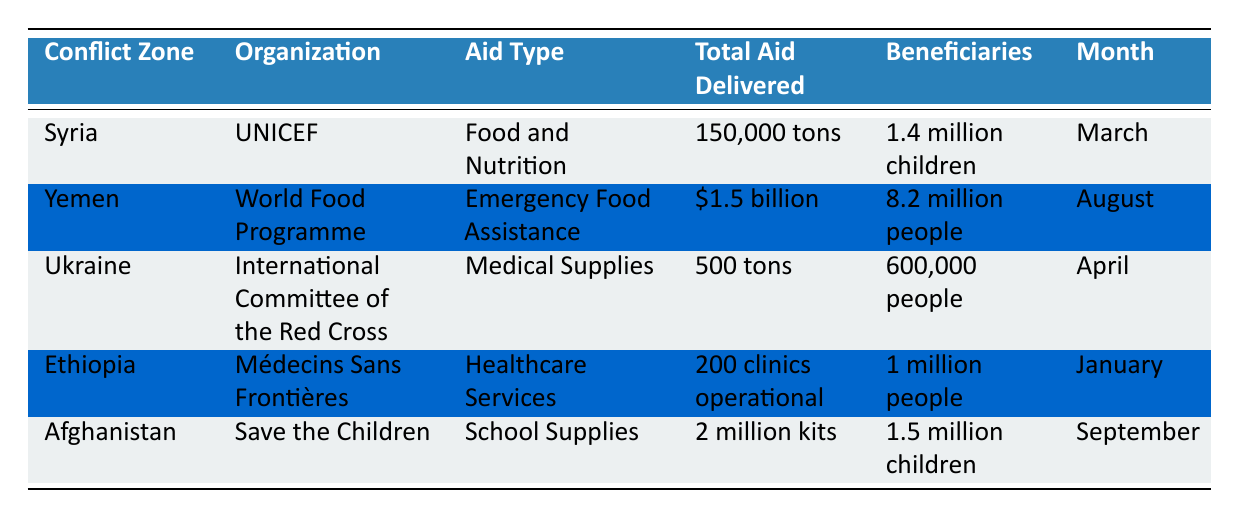What type of aid was delivered in Ukraine? The table indicates that the aid delivered in Ukraine was "Medical Supplies." This information can be found directly under the "Aid Type" column corresponding to the row for Ukraine.
Answer: Medical Supplies Which organization provided aid to Yemen? Looking through the "Organization" column, the entry for Yemen reveals that the "World Food Programme" provided aid. This can be confirmed by checking the row for Yemen.
Answer: World Food Programme How many beneficiaries received aid in Ethiopia? The table shows that 1 million people benefited from the aid delivered in Ethiopia. This information is directly available in the "Beneficiaries" column related to Ethiopia.
Answer: 1 million people Which conflict zone had the highest total aid delivered? By comparing the entries in the "Total Aid Delivered" column, Yemen has the highest value at 1.5 billion dollars. This requires evaluating each total in the list to determine the maximum.
Answer: Yemen: $1.5 billion How much food aid was delivered to Syria? According to the table, Syria received 150,000 tons of food and nutrition aid. This is explicitly stated in the row corresponding to Syria under the "Total Aid Delivered" column.
Answer: 150,000 tons Is it true that Save the Children provided aid in January? The table lists "Save the Children" as the organization for Afghanistan with aid delivered in September. Therefore, the statement is false because no aid from Save the Children was provided in January.
Answer: No What is the total number of children who received aid in both Syria and Afghanistan? In Syria, 1.4 million children received aid, and in Afghanistan, 1.5 million children did. Adding these figures together gives a total of 1.4 million + 1.5 million = 2.9 million children. This requires summing the beneficiaries in both rows for these conflict zones.
Answer: 2.9 million children Which month saw the delivery of medical supplies to Ukraine? The table indicates that medical supplies were delivered to Ukraine in April, as can be found in the "Month" column corresponding to Ukraine.
Answer: April How many clinics were operational in Ethiopia during January? The data shows that 200 clinics were operational in Ethiopia, which can be directly found in the "Total Aid Delivered" column for Ethiopia.
Answer: 200 clinics 